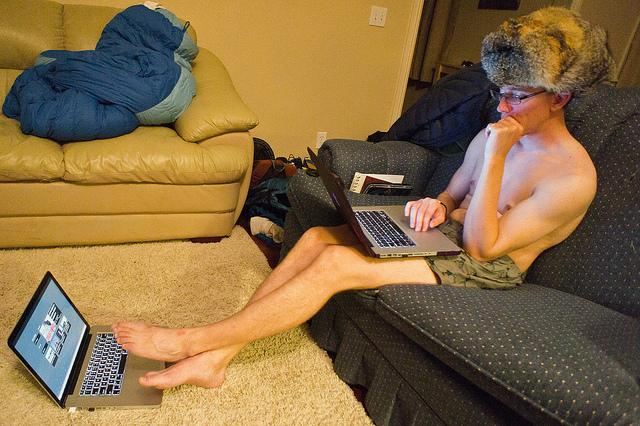What area of the computer is he touching with his fingers? Please explain your reasoning. trackpad. The trackpad is mostly only touched with fingers. 